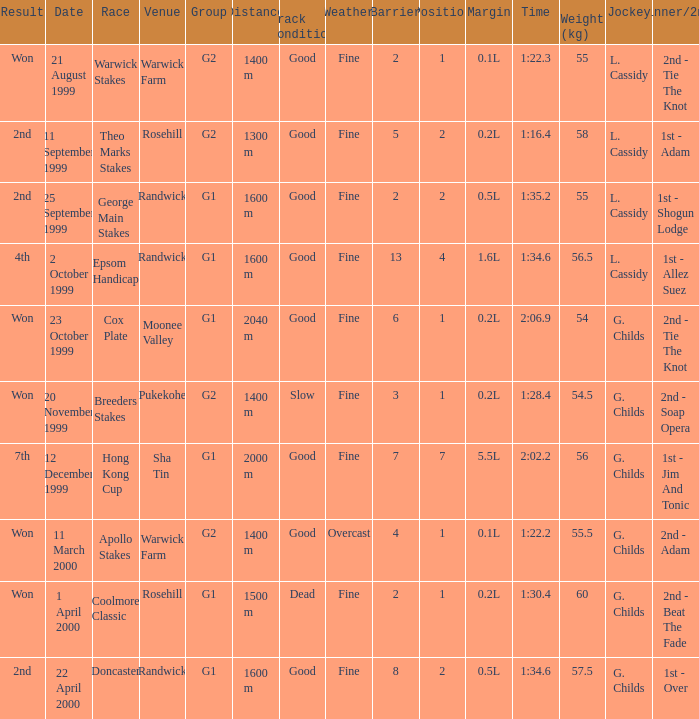List the weight for 56 kilograms. 2000 m. 